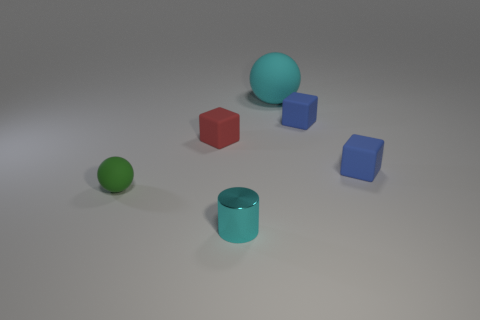Add 2 tiny red rubber cubes. How many objects exist? 8 Subtract all balls. How many objects are left? 4 Add 1 shiny things. How many shiny things are left? 2 Add 5 cyan metallic cylinders. How many cyan metallic cylinders exist? 6 Subtract 0 gray cylinders. How many objects are left? 6 Subtract all small green spheres. Subtract all big red rubber balls. How many objects are left? 5 